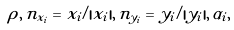<formula> <loc_0><loc_0><loc_500><loc_500>\rho , \, { n } _ { x _ { i } } = { x } _ { i } / | { x } _ { i } | , \, { n } _ { y _ { i } } = { y } _ { i } / | { y } _ { i } | , \, \alpha _ { i } ,</formula> 